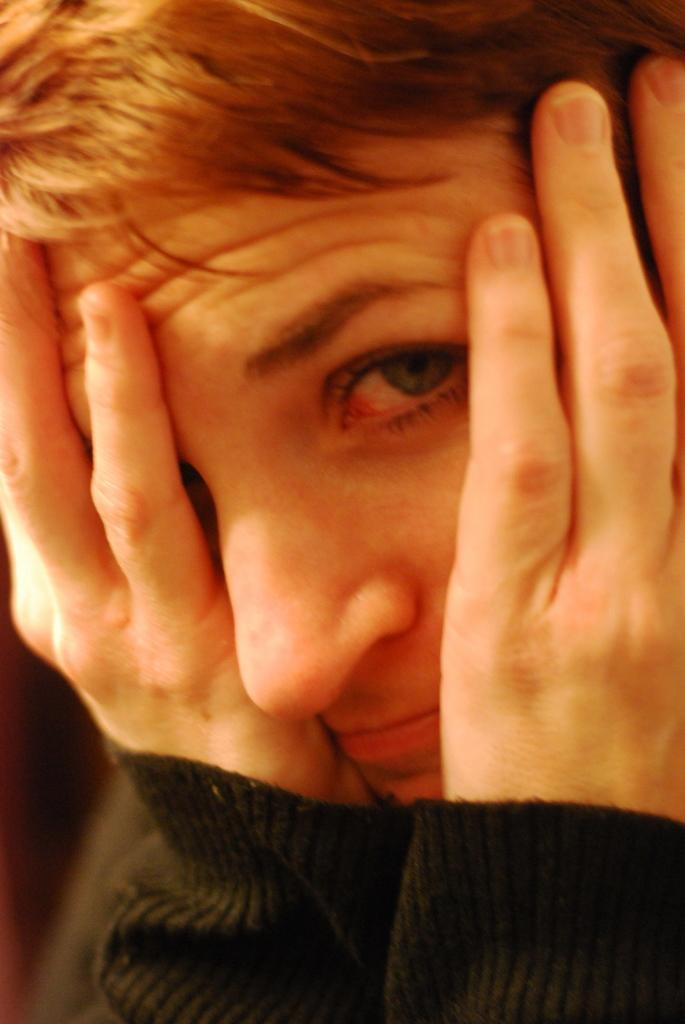What is present in the image? There is a person in the image. What is the person wearing? The person is wearing a black t-shirt. What action is the person taking in the image? The person is covering their face with their hands. What type of fog can be seen in the image? There is no fog present in the image. What memories might the person be recalling while covering their face with their hands? The image does not provide any information about the person's memories or thoughts, so it cannot be determined from the picture. 